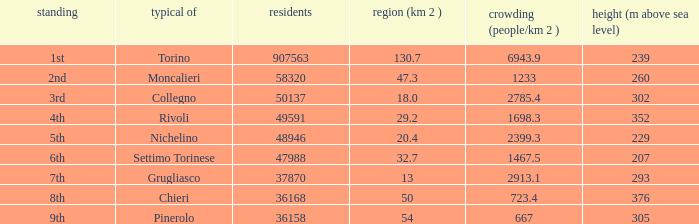What is the number of altitudes in a common with an area of 130.7 square kilometers? 1.0. 